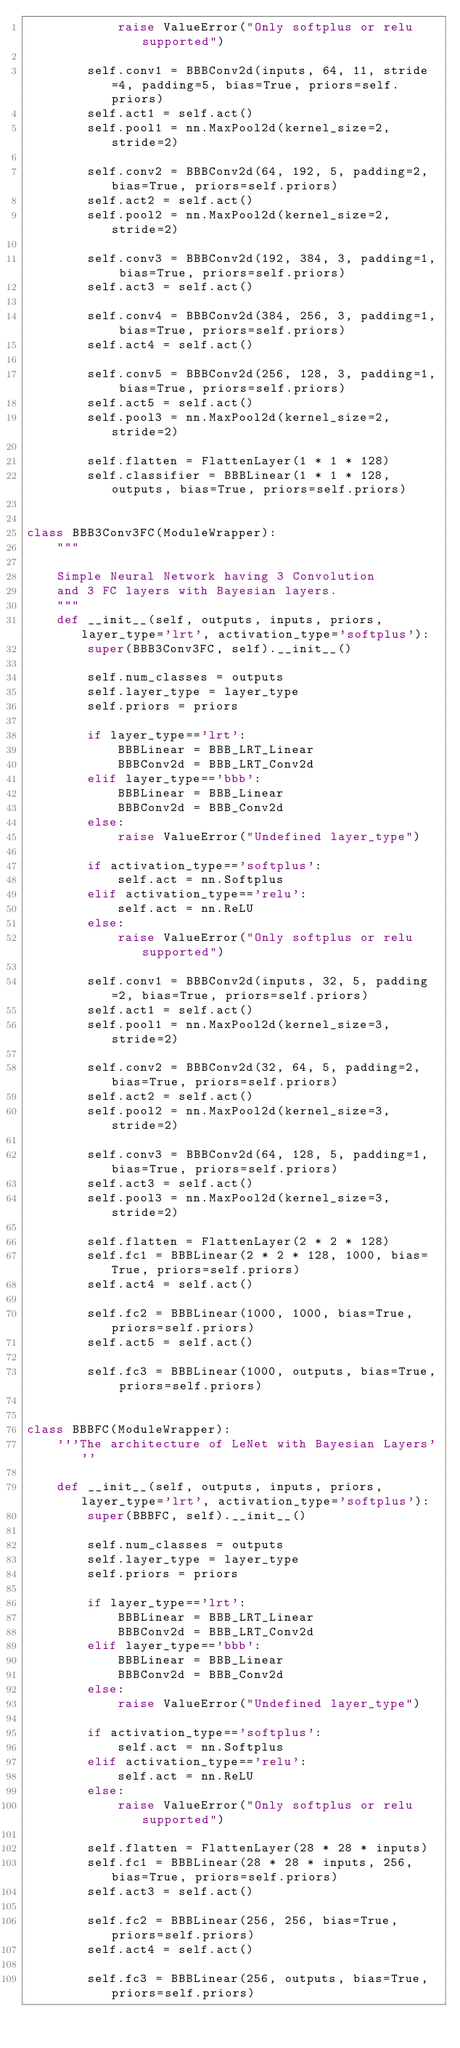<code> <loc_0><loc_0><loc_500><loc_500><_Python_>            raise ValueError("Only softplus or relu supported")

        self.conv1 = BBBConv2d(inputs, 64, 11, stride=4, padding=5, bias=True, priors=self.priors)
        self.act1 = self.act()
        self.pool1 = nn.MaxPool2d(kernel_size=2, stride=2)

        self.conv2 = BBBConv2d(64, 192, 5, padding=2, bias=True, priors=self.priors)
        self.act2 = self.act()
        self.pool2 = nn.MaxPool2d(kernel_size=2, stride=2)

        self.conv3 = BBBConv2d(192, 384, 3, padding=1, bias=True, priors=self.priors)
        self.act3 = self.act()

        self.conv4 = BBBConv2d(384, 256, 3, padding=1, bias=True, priors=self.priors)
        self.act4 = self.act()

        self.conv5 = BBBConv2d(256, 128, 3, padding=1, bias=True, priors=self.priors)
        self.act5 = self.act()
        self.pool3 = nn.MaxPool2d(kernel_size=2, stride=2)

        self.flatten = FlattenLayer(1 * 1 * 128)
        self.classifier = BBBLinear(1 * 1 * 128, outputs, bias=True, priors=self.priors)


class BBB3Conv3FC(ModuleWrapper):
    """

    Simple Neural Network having 3 Convolution
    and 3 FC layers with Bayesian layers.
    """
    def __init__(self, outputs, inputs, priors, layer_type='lrt', activation_type='softplus'):
        super(BBB3Conv3FC, self).__init__()

        self.num_classes = outputs
        self.layer_type = layer_type
        self.priors = priors

        if layer_type=='lrt':
            BBBLinear = BBB_LRT_Linear
            BBBConv2d = BBB_LRT_Conv2d
        elif layer_type=='bbb':
            BBBLinear = BBB_Linear
            BBBConv2d = BBB_Conv2d
        else:
            raise ValueError("Undefined layer_type")
        
        if activation_type=='softplus':
            self.act = nn.Softplus
        elif activation_type=='relu':
            self.act = nn.ReLU
        else:
            raise ValueError("Only softplus or relu supported")

        self.conv1 = BBBConv2d(inputs, 32, 5, padding=2, bias=True, priors=self.priors)
        self.act1 = self.act()
        self.pool1 = nn.MaxPool2d(kernel_size=3, stride=2)

        self.conv2 = BBBConv2d(32, 64, 5, padding=2, bias=True, priors=self.priors)
        self.act2 = self.act()
        self.pool2 = nn.MaxPool2d(kernel_size=3, stride=2)

        self.conv3 = BBBConv2d(64, 128, 5, padding=1, bias=True, priors=self.priors)
        self.act3 = self.act()
        self.pool3 = nn.MaxPool2d(kernel_size=3, stride=2)

        self.flatten = FlattenLayer(2 * 2 * 128)
        self.fc1 = BBBLinear(2 * 2 * 128, 1000, bias=True, priors=self.priors)
        self.act4 = self.act()

        self.fc2 = BBBLinear(1000, 1000, bias=True, priors=self.priors)
        self.act5 = self.act()

        self.fc3 = BBBLinear(1000, outputs, bias=True, priors=self.priors)

        
class BBBFC(ModuleWrapper):
    '''The architecture of LeNet with Bayesian Layers'''

    def __init__(self, outputs, inputs, priors, layer_type='lrt', activation_type='softplus'):
        super(BBBFC, self).__init__()

        self.num_classes = outputs
        self.layer_type = layer_type
        self.priors = priors

        if layer_type=='lrt':
            BBBLinear = BBB_LRT_Linear
            BBBConv2d = BBB_LRT_Conv2d
        elif layer_type=='bbb':
            BBBLinear = BBB_Linear
            BBBConv2d = BBB_Conv2d
        else:
            raise ValueError("Undefined layer_type")
        
        if activation_type=='softplus':
            self.act = nn.Softplus
        elif activation_type=='relu':
            self.act = nn.ReLU
        else:
            raise ValueError("Only softplus or relu supported")

        self.flatten = FlattenLayer(28 * 28 * inputs)
        self.fc1 = BBBLinear(28 * 28 * inputs, 256, bias=True, priors=self.priors)
        self.act3 = self.act()

        self.fc2 = BBBLinear(256, 256, bias=True, priors=self.priors)
        self.act4 = self.act()

        self.fc3 = BBBLinear(256, outputs, bias=True, priors=self.priors)</code> 